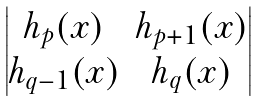<formula> <loc_0><loc_0><loc_500><loc_500>\begin{vmatrix} h _ { p } ( x ) & h _ { p + 1 } ( x ) \\ h _ { q - 1 } ( x ) & h _ { q } ( x ) \end{vmatrix}</formula> 